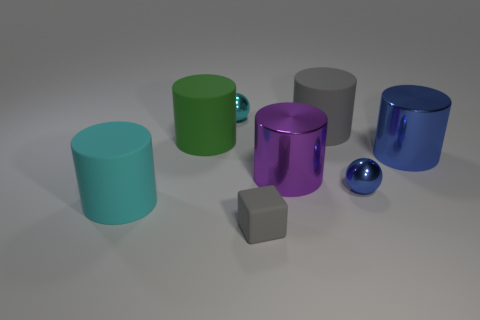What number of gray rubber spheres are there?
Your response must be concise. 0. There is a cyan rubber object; is its shape the same as the gray rubber thing behind the small rubber thing?
Make the answer very short. Yes. There is a thing that is the same color as the cube; what size is it?
Offer a very short reply. Large. How many things are either purple cylinders or small cyan shiny cylinders?
Offer a very short reply. 1. There is a object that is behind the gray thing that is behind the big cyan cylinder; what shape is it?
Offer a terse response. Sphere. There is a large metal thing behind the big purple object; is it the same shape as the purple object?
Offer a very short reply. Yes. What size is the gray block that is made of the same material as the cyan cylinder?
Offer a very short reply. Small. What number of objects are either green rubber cylinders to the left of the large gray matte object or objects that are to the left of the purple metallic cylinder?
Offer a terse response. 4. Is the number of big blue shiny cylinders on the left side of the blue metallic sphere the same as the number of cyan objects that are behind the cyan metallic object?
Keep it short and to the point. Yes. What color is the large matte object in front of the large purple thing?
Your answer should be very brief. Cyan. 